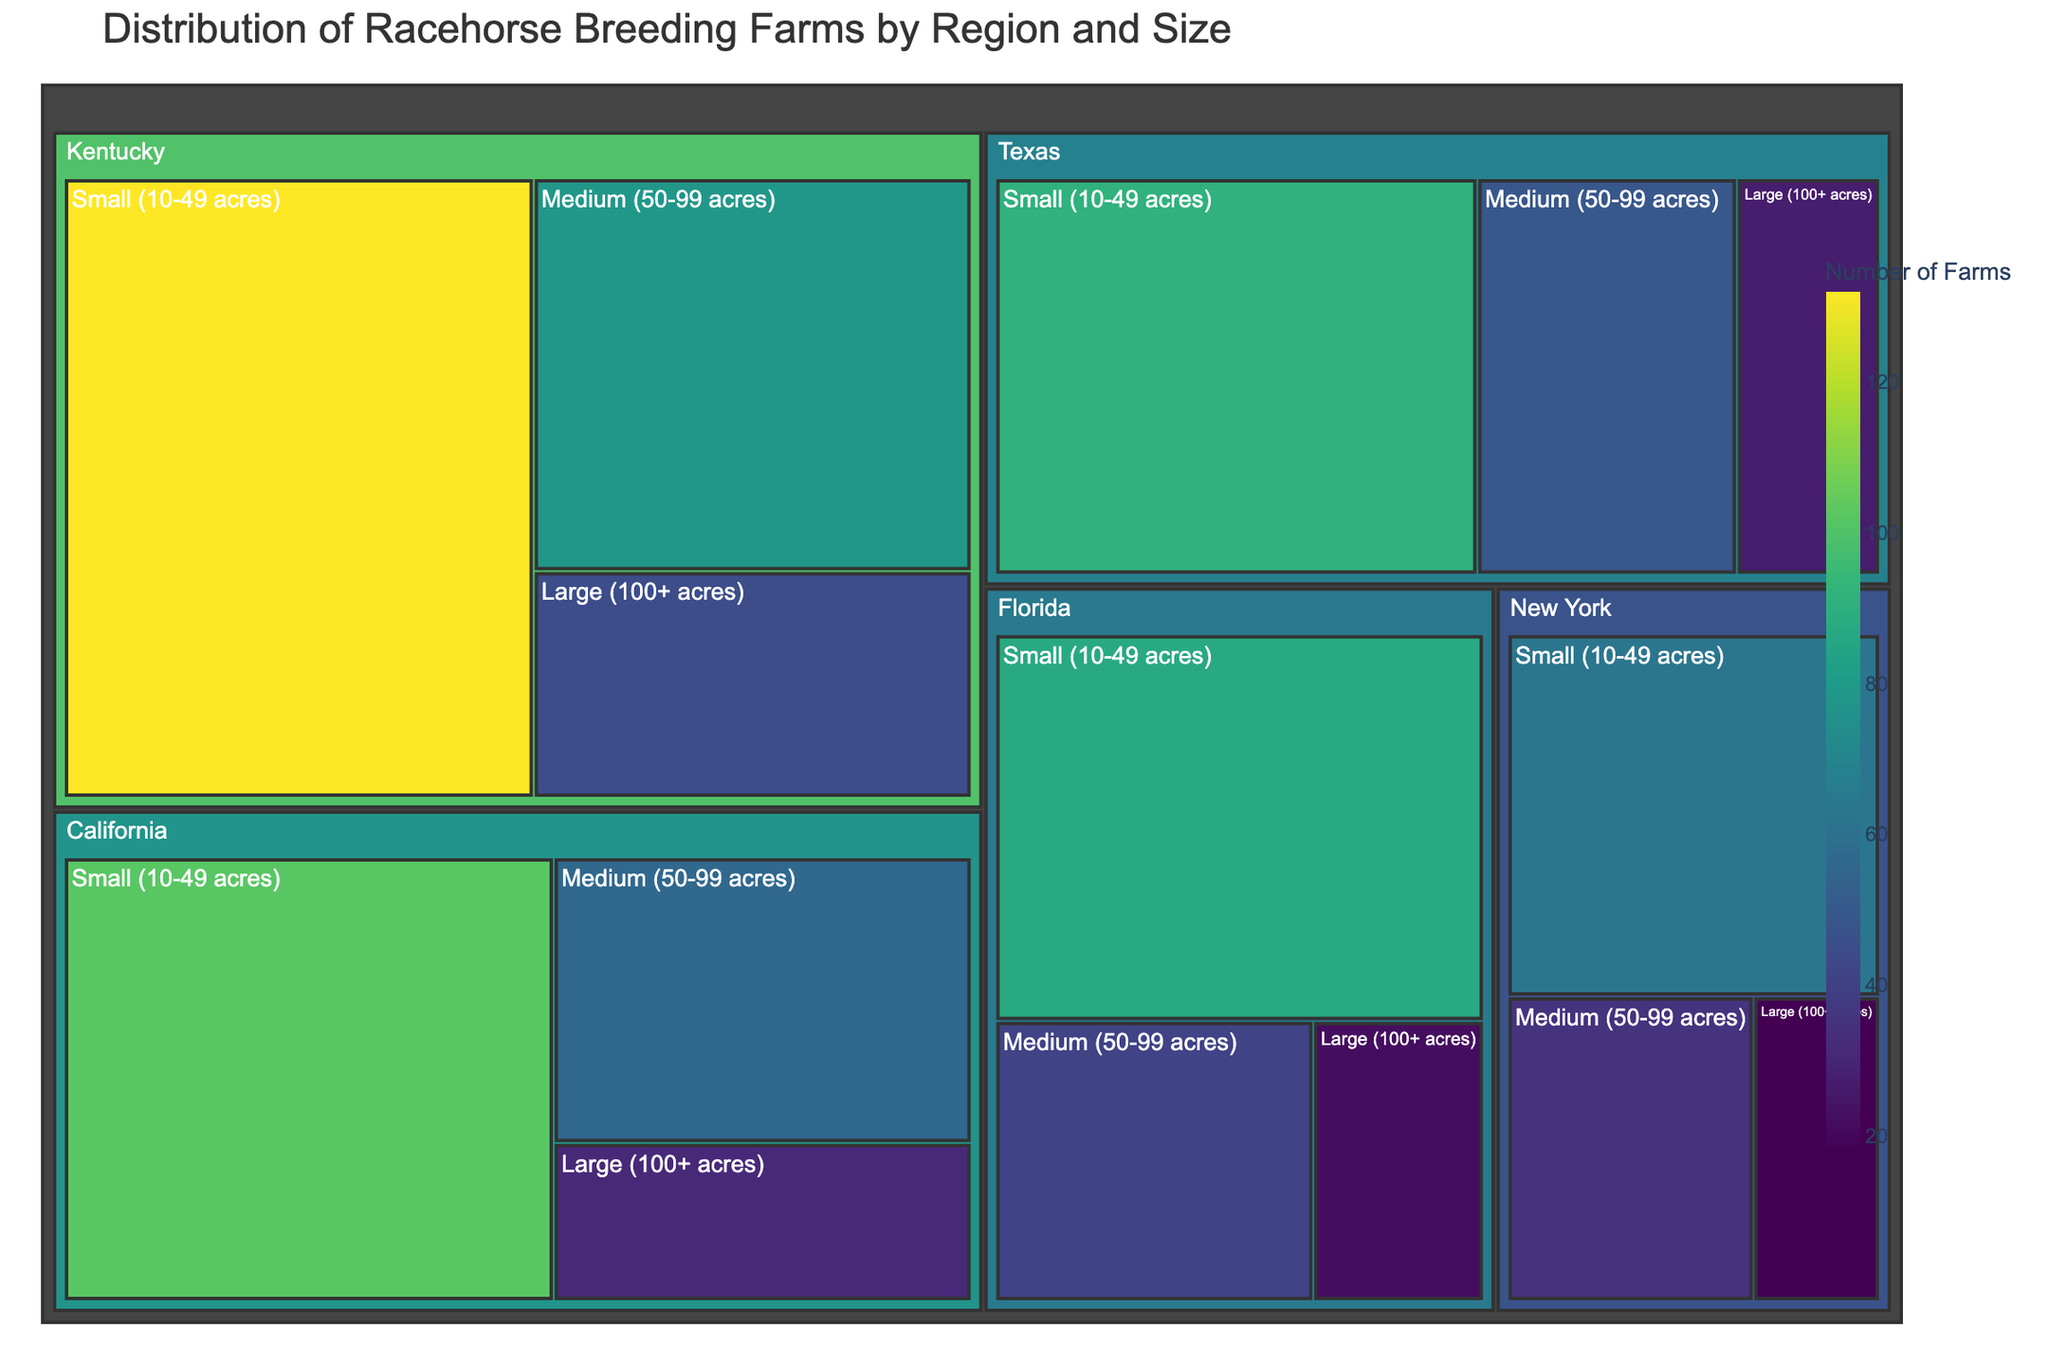How many large breeding farms are there in Kentucky? Locate the section for Kentucky in the treemap, then find the portion representing large (100+ acres) farms and read the number of farms indicated.
Answer: 45 Which region has the highest number of small breeding farms? Identify and compare the numbers of small (10-49 acres) breeding farms for each region (Kentucky, Florida, New York, California, Texas) from their respective sections in the treemap.
Answer: Kentucky What is the total number of medium-sized breeding farms in all regions combined? Add the number of medium-sized (50-99 acres) farms from all regions: (78 + 41 + 35 + 56 + 49).
Answer: 259 In which region do medium-sized breeding farms make up the largest proportion of total farms in that region? For each region, divide the number of medium-sized farms by the region's total number of farms. Comparing these proportions, we find the highest proportion. 
Kentucky: 78/(45+78+132) = 0.257
Florida: 41/(22+41+87) = 0.271
New York: 35/(18+35+63) = 0.282
California: 56/(31+56+102) = 0.281
Texas: 49/(27+49+91) = 0.281
Highest proportion is New York.
Answer: New York How does the number of breeding farms in Florida compare between large and small farm sizes? Identify the numbers of large (22) and small (87) breeding farms in Florida, then calculate the difference (87 - 22).
Answer: Small farms are more by 65 What is the combined number of large-sized breeding farms in California and Texas? Add the number of large (100+ acres) farms in California (31) and Texas (27).
Answer: 58 Which farm size category has the fewest overall farms across all regions? Add the number of farms in each size category across all regions, then compare.
Small: 132 + 87 + 63 + 102 + 91 = 475
Medium: 78 + 41 + 35 + 56 + 49 = 259
Large: 45 + 22 + 18 + 31 + 27 = 143
The category with the fewest farms is large (100+ acres).
Answer: Large farms How many more small breeding farms are there in California than in New York? Calculate the difference between the number of small breeding farms in California (102) and New York (63).
Answer: 39 What proportion of breeding farms in Texas are small (10-49 acres)? Divide the number of small breeding farms in Texas (91) by the total number of farming in Texas (27 + 49 + 91). So, 91/167 = 0.545
Answer: 0.545 